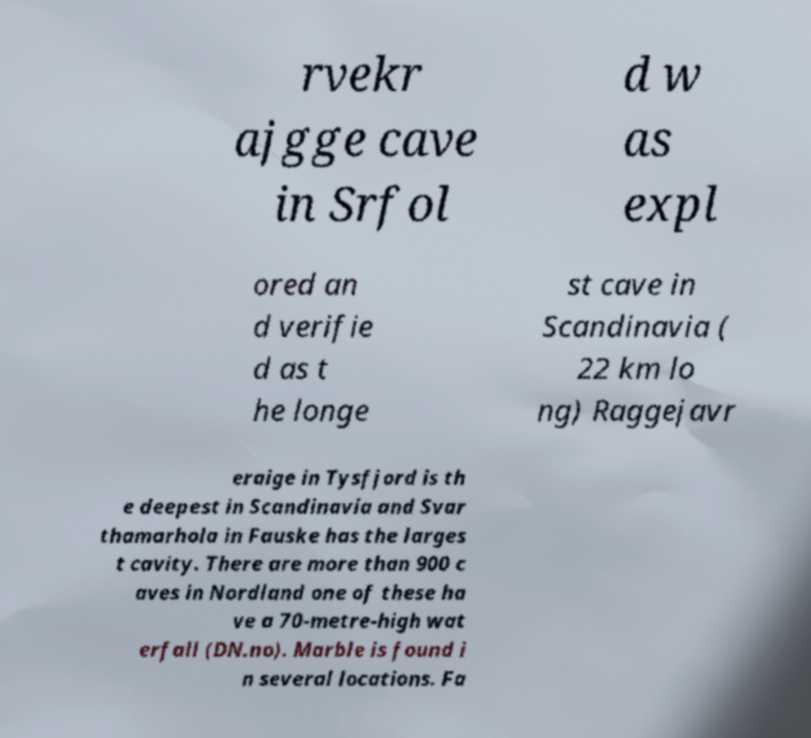Please identify and transcribe the text found in this image. rvekr ajgge cave in Srfol d w as expl ored an d verifie d as t he longe st cave in Scandinavia ( 22 km lo ng) Raggejavr eraige in Tysfjord is th e deepest in Scandinavia and Svar thamarhola in Fauske has the larges t cavity. There are more than 900 c aves in Nordland one of these ha ve a 70-metre-high wat erfall (DN.no). Marble is found i n several locations. Fa 